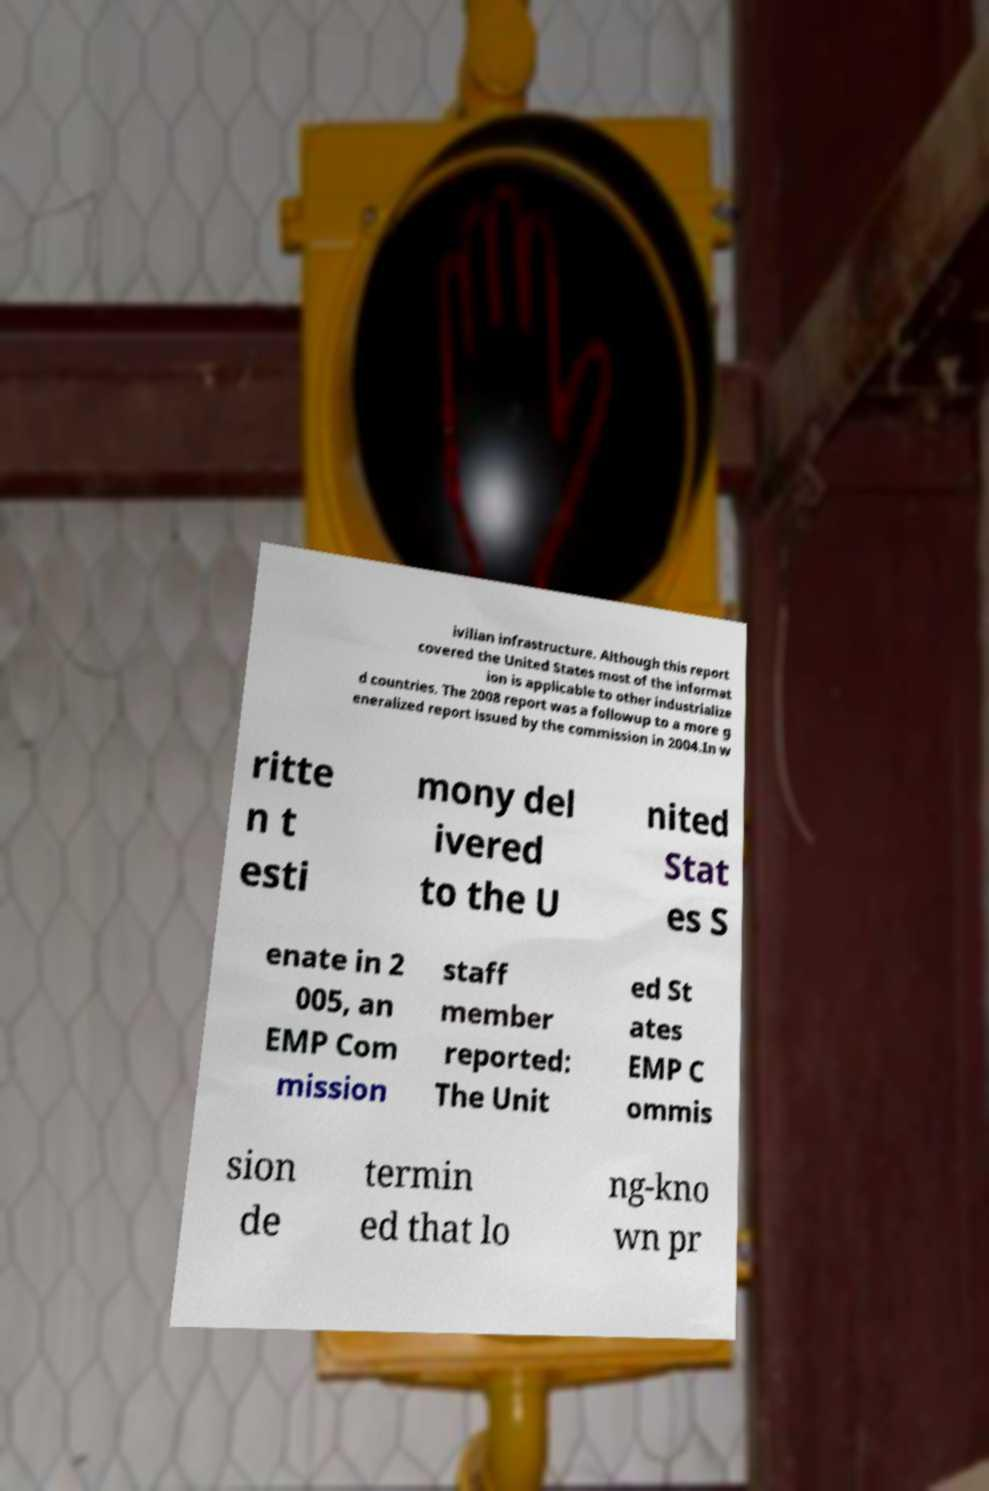Could you assist in decoding the text presented in this image and type it out clearly? ivilian infrastructure. Although this report covered the United States most of the informat ion is applicable to other industrialize d countries. The 2008 report was a followup to a more g eneralized report issued by the commission in 2004.In w ritte n t esti mony del ivered to the U nited Stat es S enate in 2 005, an EMP Com mission staff member reported: The Unit ed St ates EMP C ommis sion de termin ed that lo ng-kno wn pr 